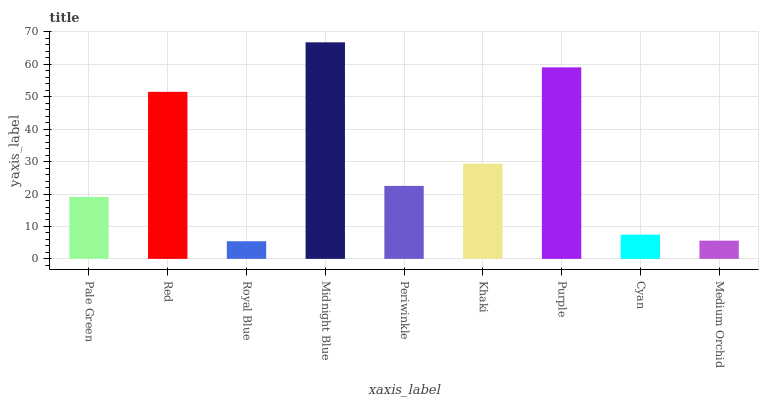Is Royal Blue the minimum?
Answer yes or no. Yes. Is Midnight Blue the maximum?
Answer yes or no. Yes. Is Red the minimum?
Answer yes or no. No. Is Red the maximum?
Answer yes or no. No. Is Red greater than Pale Green?
Answer yes or no. Yes. Is Pale Green less than Red?
Answer yes or no. Yes. Is Pale Green greater than Red?
Answer yes or no. No. Is Red less than Pale Green?
Answer yes or no. No. Is Periwinkle the high median?
Answer yes or no. Yes. Is Periwinkle the low median?
Answer yes or no. Yes. Is Cyan the high median?
Answer yes or no. No. Is Midnight Blue the low median?
Answer yes or no. No. 